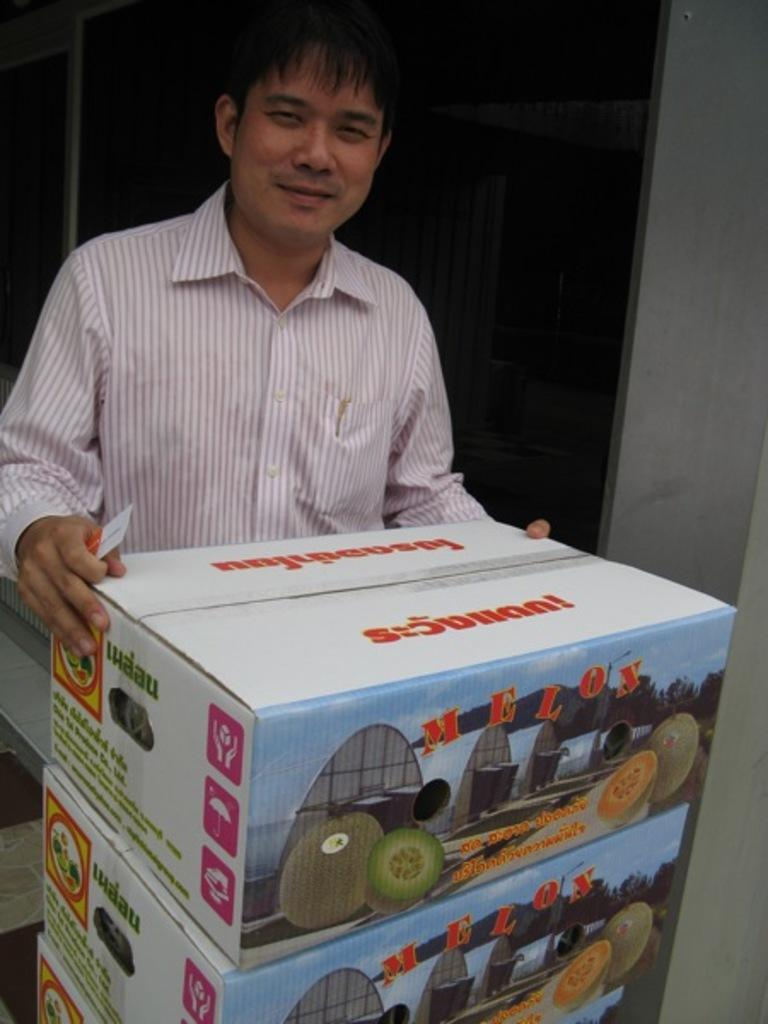<image>
Provide a brief description of the given image. A smiling Asian man gets ready to open a box of Thai melons. 